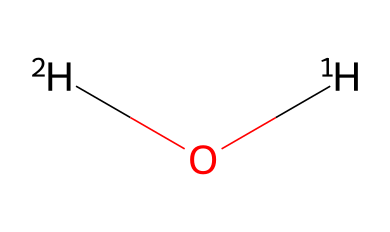How many atoms are in this molecule? The SMILES representation indicates there are two deuterium (2H) atoms and one oxygen (O) atom, totaling three atoms overall.
Answer: three What is the chemical name associated with this structure? The SMILES shows a water molecule with deuterium, indicating it is called deuterium oxide, commonly referred to as heavy water.
Answer: deuterium oxide What type of bonds are present in this molecule? The structure shows one oxygen atom bonded to two hydrogen atoms (deuterium), indicating covalent bonds.
Answer: covalent What isotopes are represented in this molecule? The SMILES notation indicates the presence of deuterium, which refers to the hydrogen isotope with one neutron.
Answer: deuterium How does the presence of deuterium affect water's molecular weight? Substituting regular hydrogen (protium) with deuterium increases the molecular weight of the water molecule due to deuterium’s additional neutron, shifting the molecular weight of water from approximately 18 to about 20.
Answer: increases Why is deuterium used for environmental tracing? Deuterium is used because its stable isotope ratio can provide insights into various environmental processes, including hydrology and climate change, making it a useful tracer.
Answer: useful tracer 